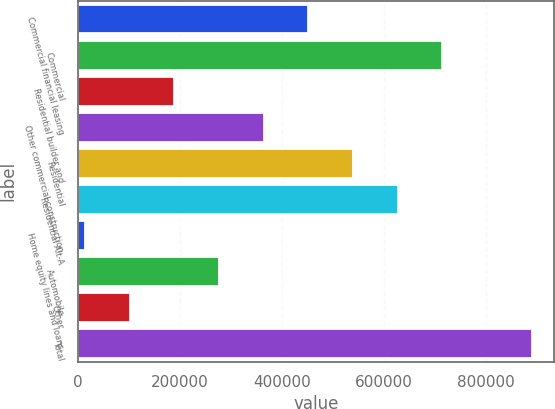Convert chart. <chart><loc_0><loc_0><loc_500><loc_500><bar_chart><fcel>Commercial financial leasing<fcel>Commercial<fcel>Residential builder and<fcel>Other commercial construction<fcel>Residential<fcel>Residential Alt-A<fcel>Home equity lines and loans<fcel>Automobile<fcel>Other<fcel>Total<nl><fcel>451449<fcel>714115<fcel>188783<fcel>363894<fcel>539004<fcel>626560<fcel>13672<fcel>276338<fcel>101227<fcel>889226<nl></chart> 